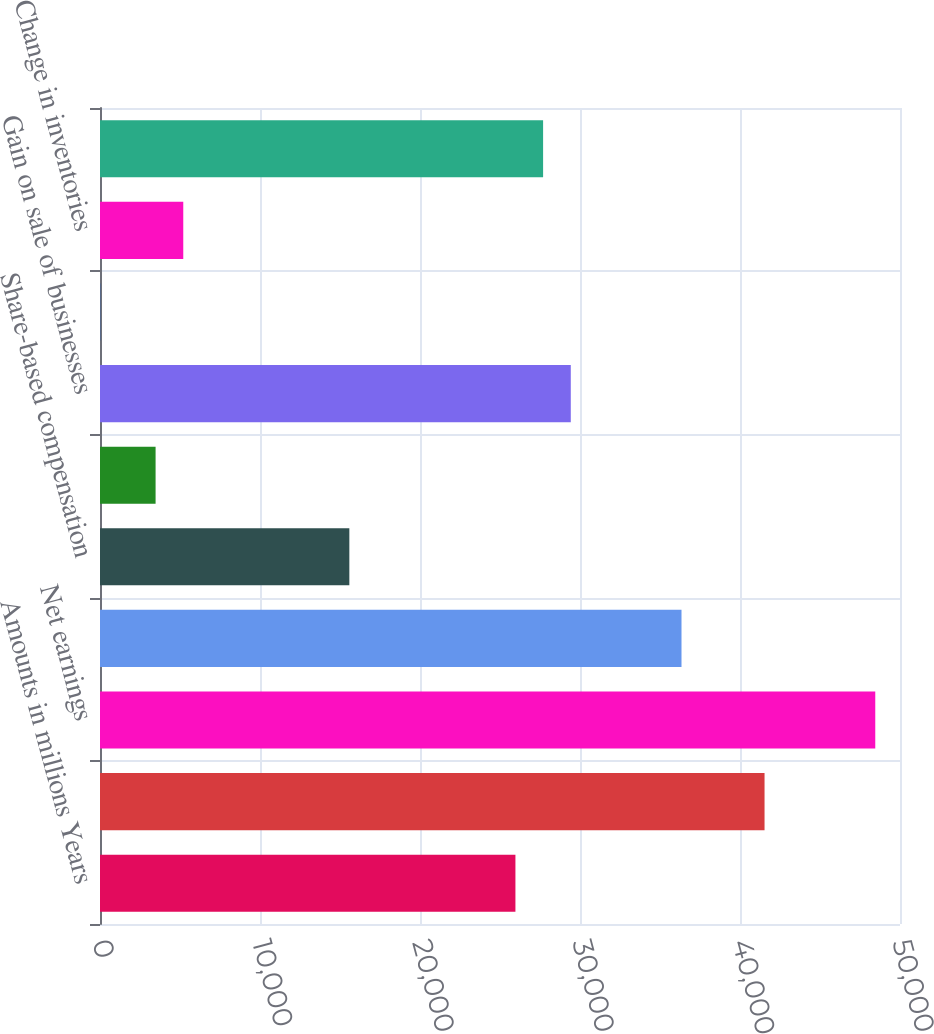<chart> <loc_0><loc_0><loc_500><loc_500><bar_chart><fcel>Amounts in millions Years<fcel>CASH AND CASH EQUIVALENTS<fcel>Net earnings<fcel>Depreciation and amortization<fcel>Share-based compensation<fcel>Deferred income taxes<fcel>Gain on sale of businesses<fcel>Change in accounts receivable<fcel>Change in inventories<fcel>Change in accounts payable<nl><fcel>25964<fcel>41534<fcel>48454<fcel>36344<fcel>15584<fcel>3474<fcel>29424<fcel>14<fcel>5204<fcel>27694<nl></chart> 